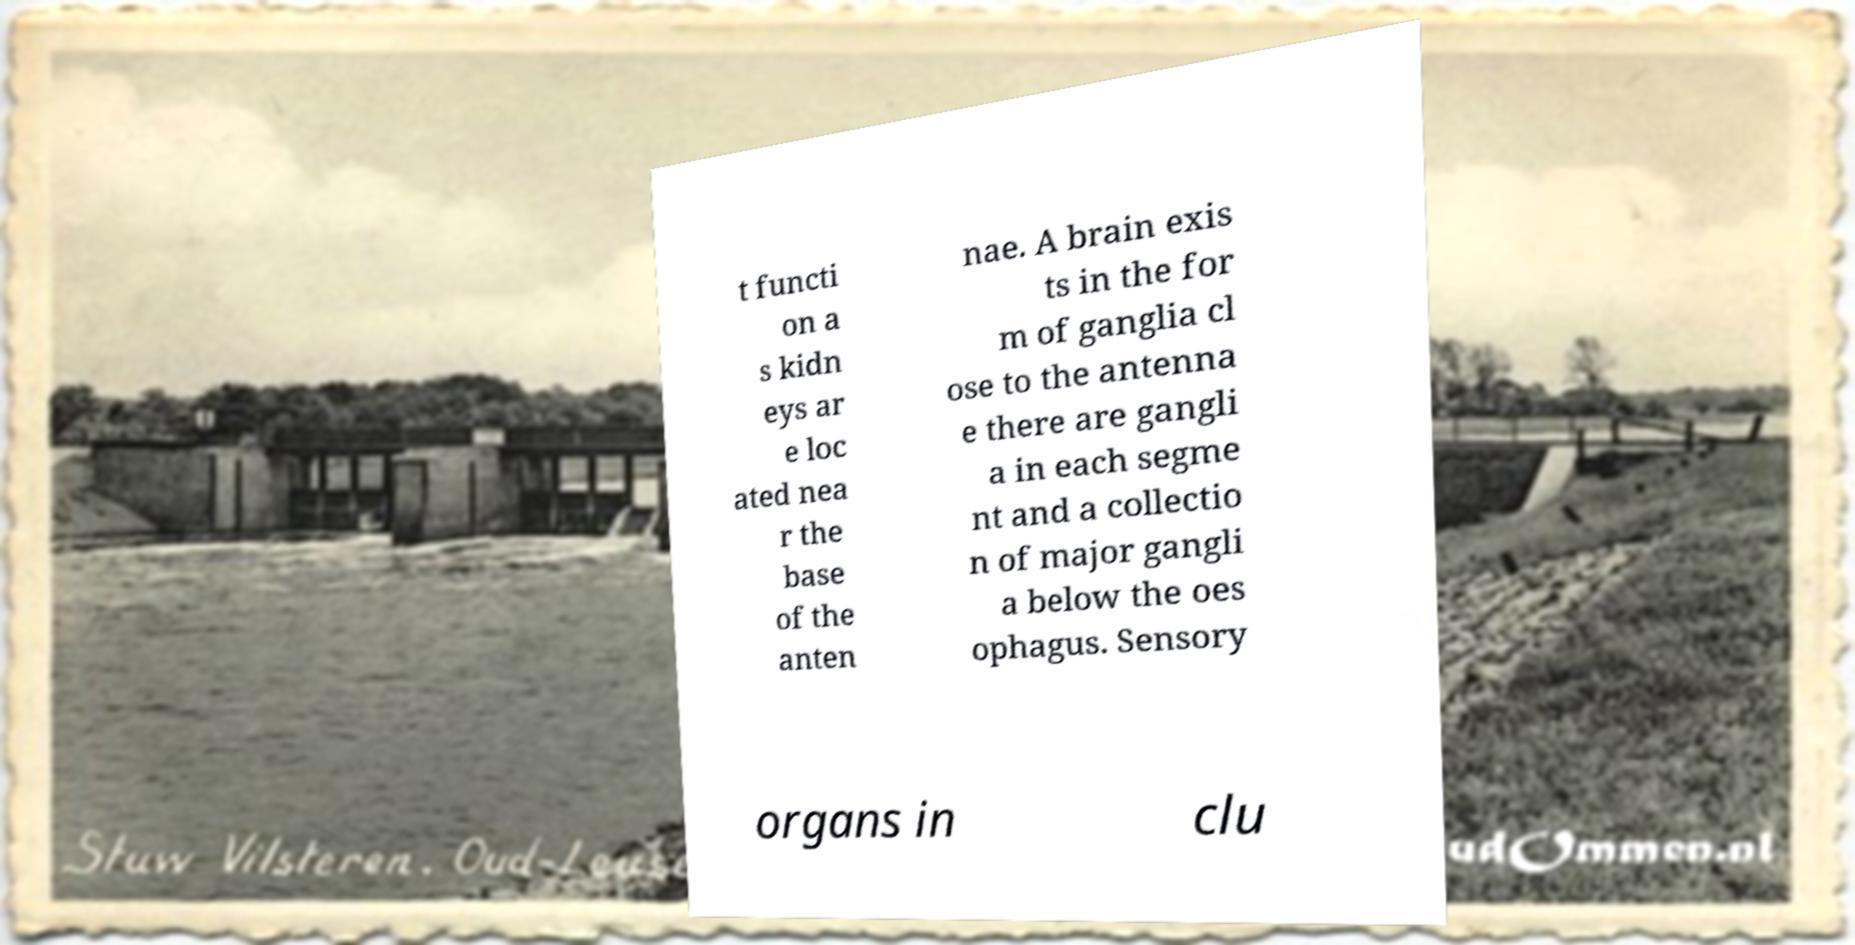Can you accurately transcribe the text from the provided image for me? t functi on a s kidn eys ar e loc ated nea r the base of the anten nae. A brain exis ts in the for m of ganglia cl ose to the antenna e there are gangli a in each segme nt and a collectio n of major gangli a below the oes ophagus. Sensory organs in clu 